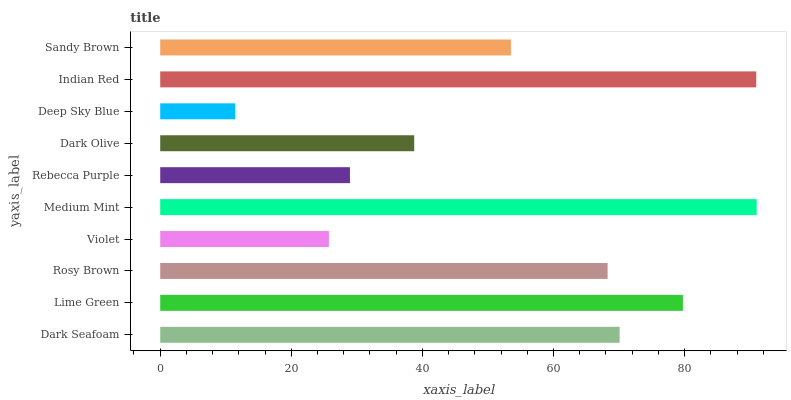Is Deep Sky Blue the minimum?
Answer yes or no. Yes. Is Medium Mint the maximum?
Answer yes or no. Yes. Is Lime Green the minimum?
Answer yes or no. No. Is Lime Green the maximum?
Answer yes or no. No. Is Lime Green greater than Dark Seafoam?
Answer yes or no. Yes. Is Dark Seafoam less than Lime Green?
Answer yes or no. Yes. Is Dark Seafoam greater than Lime Green?
Answer yes or no. No. Is Lime Green less than Dark Seafoam?
Answer yes or no. No. Is Rosy Brown the high median?
Answer yes or no. Yes. Is Sandy Brown the low median?
Answer yes or no. Yes. Is Indian Red the high median?
Answer yes or no. No. Is Dark Seafoam the low median?
Answer yes or no. No. 